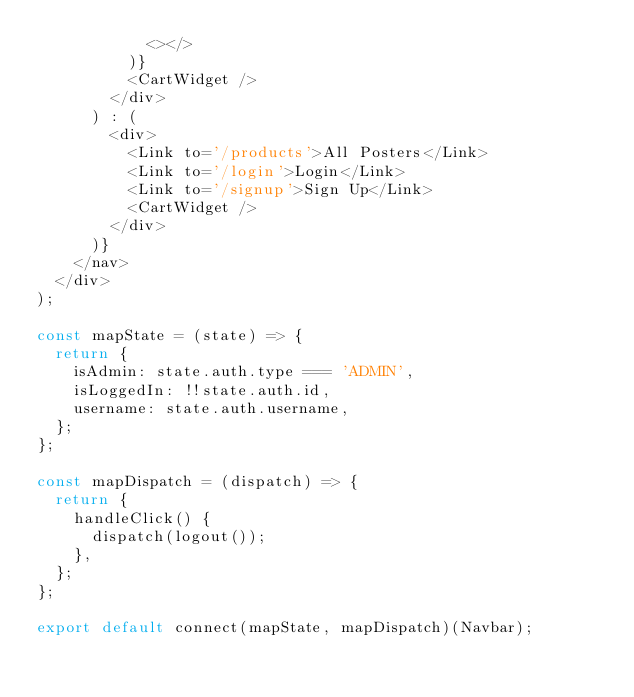Convert code to text. <code><loc_0><loc_0><loc_500><loc_500><_JavaScript_>            <></>
          )}
          <CartWidget />
        </div>
      ) : (
        <div>
          <Link to='/products'>All Posters</Link>
          <Link to='/login'>Login</Link>
          <Link to='/signup'>Sign Up</Link>
          <CartWidget />
        </div>
      )}
    </nav>
  </div>
);

const mapState = (state) => {
  return {
    isAdmin: state.auth.type === 'ADMIN',
    isLoggedIn: !!state.auth.id,
    username: state.auth.username,
  };
};

const mapDispatch = (dispatch) => {
  return {
    handleClick() {
      dispatch(logout());
    },
  };
};

export default connect(mapState, mapDispatch)(Navbar);
</code> 